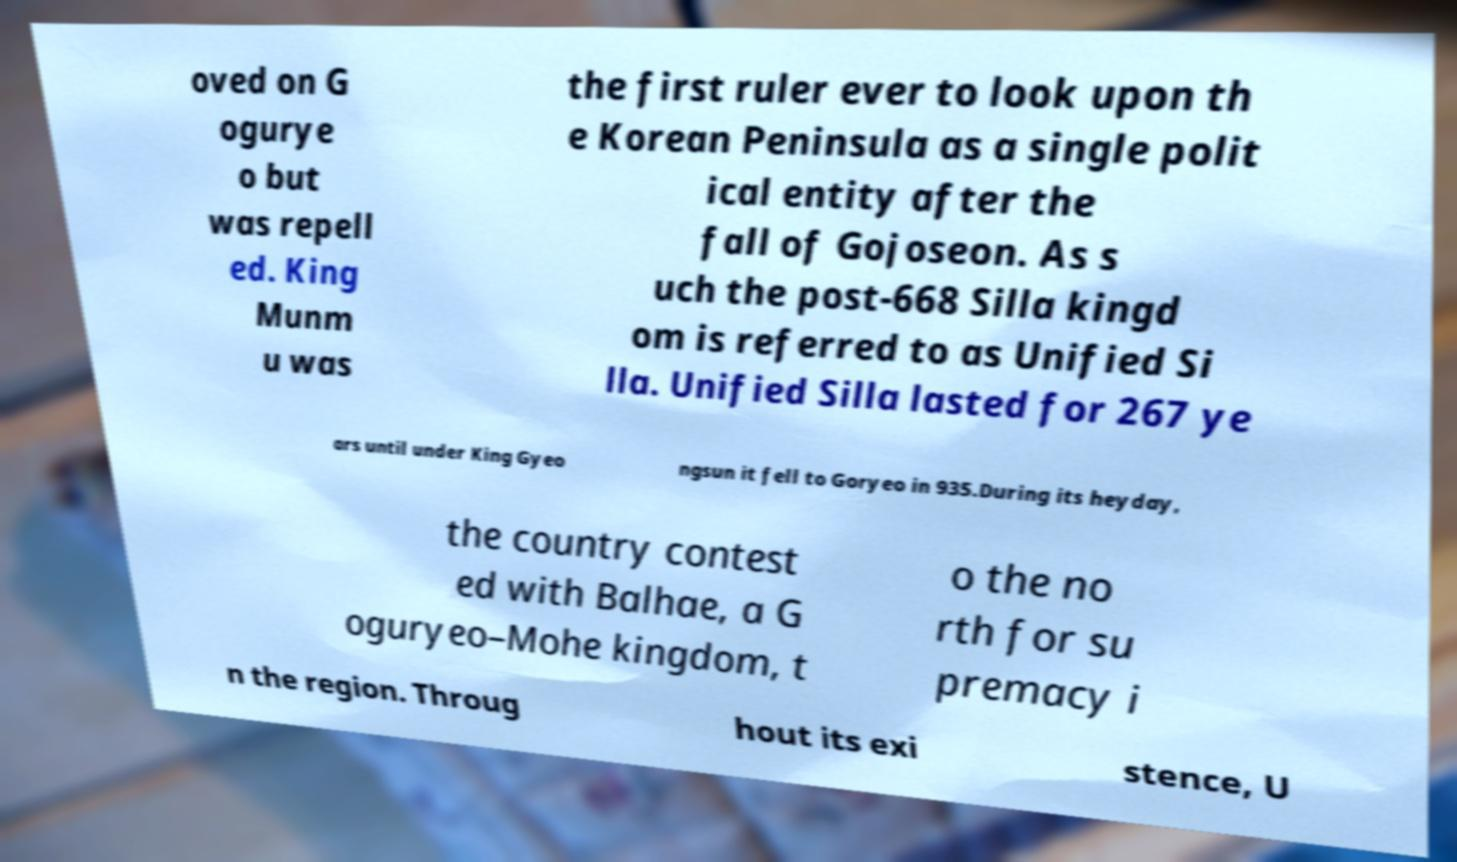Please read and relay the text visible in this image. What does it say? oved on G ogurye o but was repell ed. King Munm u was the first ruler ever to look upon th e Korean Peninsula as a single polit ical entity after the fall of Gojoseon. As s uch the post-668 Silla kingd om is referred to as Unified Si lla. Unified Silla lasted for 267 ye ars until under King Gyeo ngsun it fell to Goryeo in 935.During its heyday, the country contest ed with Balhae, a G oguryeo–Mohe kingdom, t o the no rth for su premacy i n the region. Throug hout its exi stence, U 